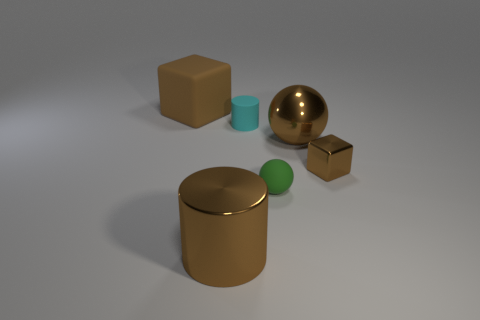Is the color of the shiny cylinder the same as the tiny metallic cube?
Provide a short and direct response. Yes. The tiny green matte thing is what shape?
Your response must be concise. Sphere. Is the tiny green object made of the same material as the small brown object?
Provide a short and direct response. No. There is a big brown object on the left side of the large shiny object that is in front of the brown shiny block; is there a tiny cyan rubber cylinder left of it?
Your answer should be very brief. No. How many other things are the same shape as the tiny metal object?
Your response must be concise. 1. What is the shape of the matte thing that is on the right side of the metal cylinder and behind the tiny brown shiny thing?
Keep it short and to the point. Cylinder. What is the color of the block that is in front of the brown object that is left of the large metal thing that is to the left of the green rubber object?
Give a very brief answer. Brown. Are there more cubes left of the tiny cylinder than small spheres that are on the right side of the tiny matte ball?
Your response must be concise. Yes. How many other objects are the same size as the green rubber sphere?
Ensure brevity in your answer.  2. What size is the metallic cylinder that is the same color as the big ball?
Provide a short and direct response. Large. 